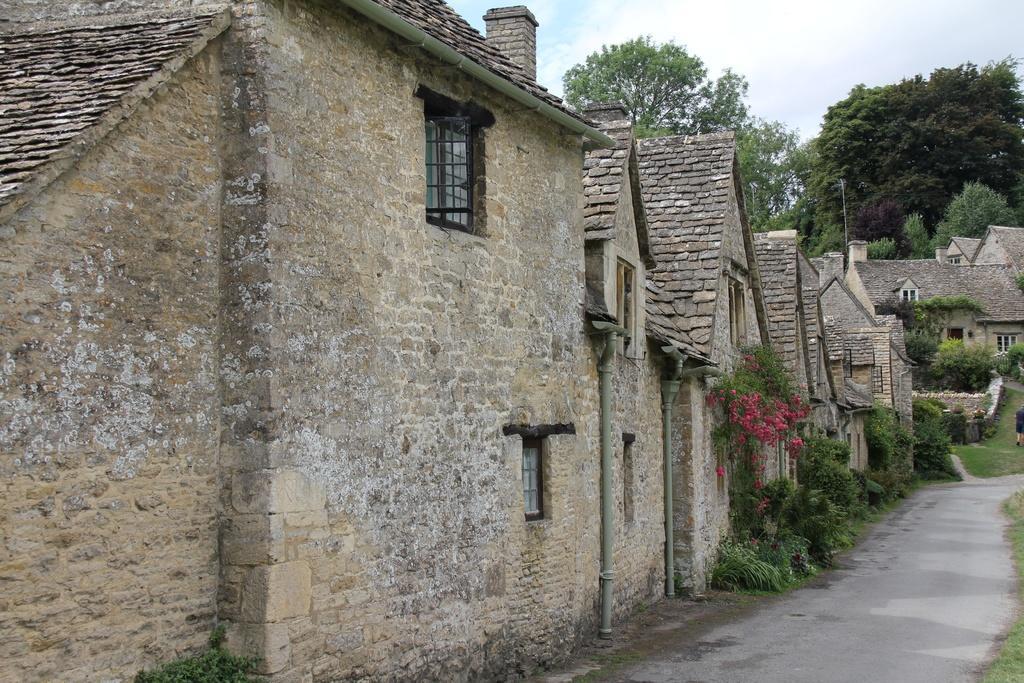How would you summarize this image in a sentence or two? This image is taken outdoors. At the top of the image there is the sky with clouds. At the bottom of the image there is a road and there is a ground with grass on it. In the background there are a few trees. In the middle of the image there are a few houses with walls, windows, doors and roofs. There are a few plants and trees on the ground. 